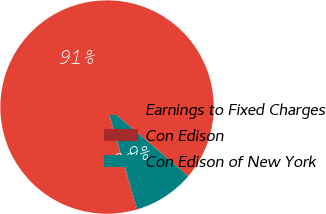Convert chart to OTSL. <chart><loc_0><loc_0><loc_500><loc_500><pie_chart><fcel>Earnings to Fixed Charges<fcel>Con Edison<fcel>Con Edison of New York<nl><fcel>90.65%<fcel>0.15%<fcel>9.2%<nl></chart> 